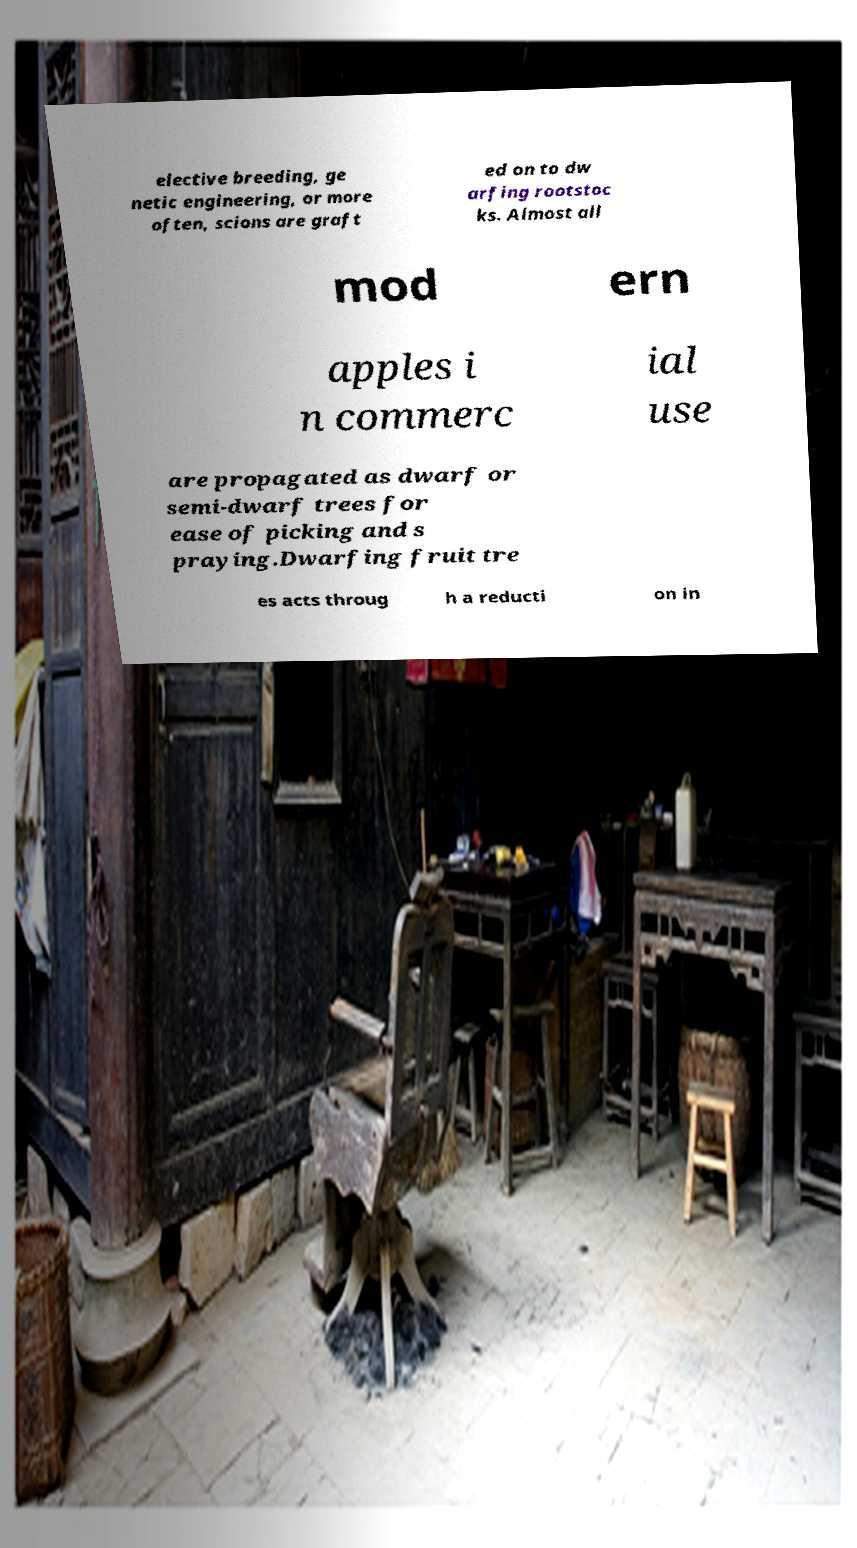Can you accurately transcribe the text from the provided image for me? elective breeding, ge netic engineering, or more often, scions are graft ed on to dw arfing rootstoc ks. Almost all mod ern apples i n commerc ial use are propagated as dwarf or semi-dwarf trees for ease of picking and s praying.Dwarfing fruit tre es acts throug h a reducti on in 